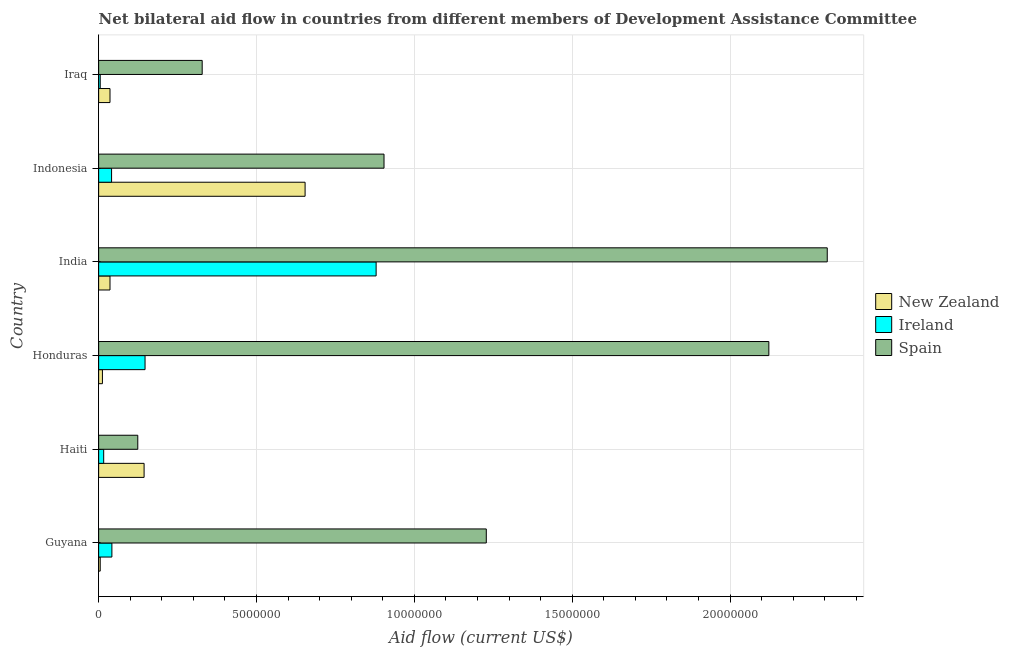How many groups of bars are there?
Make the answer very short. 6. Are the number of bars per tick equal to the number of legend labels?
Keep it short and to the point. Yes. Are the number of bars on each tick of the Y-axis equal?
Provide a succinct answer. Yes. How many bars are there on the 6th tick from the bottom?
Offer a very short reply. 3. What is the label of the 1st group of bars from the top?
Provide a short and direct response. Iraq. In how many cases, is the number of bars for a given country not equal to the number of legend labels?
Offer a terse response. 0. What is the amount of aid provided by spain in Guyana?
Your answer should be compact. 1.23e+07. Across all countries, what is the maximum amount of aid provided by ireland?
Ensure brevity in your answer.  8.79e+06. Across all countries, what is the minimum amount of aid provided by new zealand?
Make the answer very short. 5.00e+04. In which country was the amount of aid provided by spain maximum?
Ensure brevity in your answer.  India. In which country was the amount of aid provided by spain minimum?
Give a very brief answer. Haiti. What is the total amount of aid provided by spain in the graph?
Provide a succinct answer. 7.02e+07. What is the difference between the amount of aid provided by ireland in Haiti and that in Honduras?
Offer a terse response. -1.31e+06. What is the difference between the amount of aid provided by new zealand in Honduras and the amount of aid provided by ireland in Guyana?
Give a very brief answer. -3.00e+05. What is the average amount of aid provided by ireland per country?
Your answer should be compact. 1.88e+06. What is the difference between the amount of aid provided by ireland and amount of aid provided by new zealand in Indonesia?
Give a very brief answer. -6.13e+06. What is the ratio of the amount of aid provided by spain in Guyana to that in Iraq?
Offer a terse response. 3.74. Is the difference between the amount of aid provided by spain in India and Iraq greater than the difference between the amount of aid provided by ireland in India and Iraq?
Your response must be concise. Yes. What is the difference between the highest and the second highest amount of aid provided by new zealand?
Offer a very short reply. 5.10e+06. What is the difference between the highest and the lowest amount of aid provided by ireland?
Keep it short and to the point. 8.74e+06. Is the sum of the amount of aid provided by spain in Honduras and Iraq greater than the maximum amount of aid provided by ireland across all countries?
Provide a succinct answer. Yes. What does the 1st bar from the top in India represents?
Give a very brief answer. Spain. What does the 2nd bar from the bottom in India represents?
Your answer should be compact. Ireland. Is it the case that in every country, the sum of the amount of aid provided by new zealand and amount of aid provided by ireland is greater than the amount of aid provided by spain?
Give a very brief answer. No. How many bars are there?
Your answer should be compact. 18. Are all the bars in the graph horizontal?
Your answer should be compact. Yes. How many countries are there in the graph?
Keep it short and to the point. 6. What is the difference between two consecutive major ticks on the X-axis?
Your response must be concise. 5.00e+06. Does the graph contain any zero values?
Make the answer very short. No. Where does the legend appear in the graph?
Your response must be concise. Center right. What is the title of the graph?
Make the answer very short. Net bilateral aid flow in countries from different members of Development Assistance Committee. What is the Aid flow (current US$) of Ireland in Guyana?
Your response must be concise. 4.20e+05. What is the Aid flow (current US$) of Spain in Guyana?
Your answer should be compact. 1.23e+07. What is the Aid flow (current US$) in New Zealand in Haiti?
Keep it short and to the point. 1.44e+06. What is the Aid flow (current US$) in Spain in Haiti?
Offer a very short reply. 1.24e+06. What is the Aid flow (current US$) in Ireland in Honduras?
Offer a terse response. 1.47e+06. What is the Aid flow (current US$) in Spain in Honduras?
Provide a succinct answer. 2.12e+07. What is the Aid flow (current US$) in New Zealand in India?
Keep it short and to the point. 3.60e+05. What is the Aid flow (current US$) of Ireland in India?
Ensure brevity in your answer.  8.79e+06. What is the Aid flow (current US$) of Spain in India?
Make the answer very short. 2.31e+07. What is the Aid flow (current US$) of New Zealand in Indonesia?
Keep it short and to the point. 6.54e+06. What is the Aid flow (current US$) in Ireland in Indonesia?
Keep it short and to the point. 4.10e+05. What is the Aid flow (current US$) of Spain in Indonesia?
Provide a succinct answer. 9.04e+06. What is the Aid flow (current US$) of Ireland in Iraq?
Provide a succinct answer. 5.00e+04. What is the Aid flow (current US$) in Spain in Iraq?
Offer a very short reply. 3.28e+06. Across all countries, what is the maximum Aid flow (current US$) of New Zealand?
Offer a very short reply. 6.54e+06. Across all countries, what is the maximum Aid flow (current US$) of Ireland?
Ensure brevity in your answer.  8.79e+06. Across all countries, what is the maximum Aid flow (current US$) in Spain?
Provide a short and direct response. 2.31e+07. Across all countries, what is the minimum Aid flow (current US$) of Spain?
Your answer should be compact. 1.24e+06. What is the total Aid flow (current US$) in New Zealand in the graph?
Offer a very short reply. 8.87e+06. What is the total Aid flow (current US$) in Ireland in the graph?
Give a very brief answer. 1.13e+07. What is the total Aid flow (current US$) of Spain in the graph?
Provide a succinct answer. 7.02e+07. What is the difference between the Aid flow (current US$) of New Zealand in Guyana and that in Haiti?
Provide a succinct answer. -1.39e+06. What is the difference between the Aid flow (current US$) of Ireland in Guyana and that in Haiti?
Keep it short and to the point. 2.60e+05. What is the difference between the Aid flow (current US$) of Spain in Guyana and that in Haiti?
Offer a very short reply. 1.10e+07. What is the difference between the Aid flow (current US$) in Ireland in Guyana and that in Honduras?
Your answer should be compact. -1.05e+06. What is the difference between the Aid flow (current US$) in Spain in Guyana and that in Honduras?
Make the answer very short. -8.95e+06. What is the difference between the Aid flow (current US$) in New Zealand in Guyana and that in India?
Offer a very short reply. -3.10e+05. What is the difference between the Aid flow (current US$) in Ireland in Guyana and that in India?
Give a very brief answer. -8.37e+06. What is the difference between the Aid flow (current US$) in Spain in Guyana and that in India?
Provide a short and direct response. -1.08e+07. What is the difference between the Aid flow (current US$) in New Zealand in Guyana and that in Indonesia?
Your answer should be very brief. -6.49e+06. What is the difference between the Aid flow (current US$) in Ireland in Guyana and that in Indonesia?
Your answer should be very brief. 10000. What is the difference between the Aid flow (current US$) of Spain in Guyana and that in Indonesia?
Your response must be concise. 3.24e+06. What is the difference between the Aid flow (current US$) in New Zealand in Guyana and that in Iraq?
Your answer should be very brief. -3.10e+05. What is the difference between the Aid flow (current US$) in Ireland in Guyana and that in Iraq?
Ensure brevity in your answer.  3.70e+05. What is the difference between the Aid flow (current US$) of Spain in Guyana and that in Iraq?
Your answer should be very brief. 9.00e+06. What is the difference between the Aid flow (current US$) of New Zealand in Haiti and that in Honduras?
Your answer should be very brief. 1.32e+06. What is the difference between the Aid flow (current US$) of Ireland in Haiti and that in Honduras?
Provide a succinct answer. -1.31e+06. What is the difference between the Aid flow (current US$) in Spain in Haiti and that in Honduras?
Provide a short and direct response. -2.00e+07. What is the difference between the Aid flow (current US$) of New Zealand in Haiti and that in India?
Keep it short and to the point. 1.08e+06. What is the difference between the Aid flow (current US$) of Ireland in Haiti and that in India?
Ensure brevity in your answer.  -8.63e+06. What is the difference between the Aid flow (current US$) of Spain in Haiti and that in India?
Make the answer very short. -2.18e+07. What is the difference between the Aid flow (current US$) in New Zealand in Haiti and that in Indonesia?
Offer a terse response. -5.10e+06. What is the difference between the Aid flow (current US$) in Ireland in Haiti and that in Indonesia?
Provide a short and direct response. -2.50e+05. What is the difference between the Aid flow (current US$) in Spain in Haiti and that in Indonesia?
Keep it short and to the point. -7.80e+06. What is the difference between the Aid flow (current US$) of New Zealand in Haiti and that in Iraq?
Your answer should be compact. 1.08e+06. What is the difference between the Aid flow (current US$) in Spain in Haiti and that in Iraq?
Keep it short and to the point. -2.04e+06. What is the difference between the Aid flow (current US$) in New Zealand in Honduras and that in India?
Offer a terse response. -2.40e+05. What is the difference between the Aid flow (current US$) in Ireland in Honduras and that in India?
Your answer should be very brief. -7.32e+06. What is the difference between the Aid flow (current US$) of Spain in Honduras and that in India?
Provide a short and direct response. -1.85e+06. What is the difference between the Aid flow (current US$) in New Zealand in Honduras and that in Indonesia?
Offer a terse response. -6.42e+06. What is the difference between the Aid flow (current US$) of Ireland in Honduras and that in Indonesia?
Your response must be concise. 1.06e+06. What is the difference between the Aid flow (current US$) in Spain in Honduras and that in Indonesia?
Make the answer very short. 1.22e+07. What is the difference between the Aid flow (current US$) in Ireland in Honduras and that in Iraq?
Provide a succinct answer. 1.42e+06. What is the difference between the Aid flow (current US$) in Spain in Honduras and that in Iraq?
Your answer should be compact. 1.80e+07. What is the difference between the Aid flow (current US$) of New Zealand in India and that in Indonesia?
Give a very brief answer. -6.18e+06. What is the difference between the Aid flow (current US$) in Ireland in India and that in Indonesia?
Provide a short and direct response. 8.38e+06. What is the difference between the Aid flow (current US$) of Spain in India and that in Indonesia?
Make the answer very short. 1.40e+07. What is the difference between the Aid flow (current US$) of Ireland in India and that in Iraq?
Your answer should be very brief. 8.74e+06. What is the difference between the Aid flow (current US$) in Spain in India and that in Iraq?
Offer a very short reply. 1.98e+07. What is the difference between the Aid flow (current US$) in New Zealand in Indonesia and that in Iraq?
Make the answer very short. 6.18e+06. What is the difference between the Aid flow (current US$) in Ireland in Indonesia and that in Iraq?
Your response must be concise. 3.60e+05. What is the difference between the Aid flow (current US$) in Spain in Indonesia and that in Iraq?
Offer a very short reply. 5.76e+06. What is the difference between the Aid flow (current US$) of New Zealand in Guyana and the Aid flow (current US$) of Ireland in Haiti?
Provide a short and direct response. -1.10e+05. What is the difference between the Aid flow (current US$) of New Zealand in Guyana and the Aid flow (current US$) of Spain in Haiti?
Make the answer very short. -1.19e+06. What is the difference between the Aid flow (current US$) in Ireland in Guyana and the Aid flow (current US$) in Spain in Haiti?
Provide a short and direct response. -8.20e+05. What is the difference between the Aid flow (current US$) in New Zealand in Guyana and the Aid flow (current US$) in Ireland in Honduras?
Provide a succinct answer. -1.42e+06. What is the difference between the Aid flow (current US$) in New Zealand in Guyana and the Aid flow (current US$) in Spain in Honduras?
Your answer should be very brief. -2.12e+07. What is the difference between the Aid flow (current US$) in Ireland in Guyana and the Aid flow (current US$) in Spain in Honduras?
Offer a very short reply. -2.08e+07. What is the difference between the Aid flow (current US$) in New Zealand in Guyana and the Aid flow (current US$) in Ireland in India?
Your response must be concise. -8.74e+06. What is the difference between the Aid flow (current US$) in New Zealand in Guyana and the Aid flow (current US$) in Spain in India?
Provide a short and direct response. -2.30e+07. What is the difference between the Aid flow (current US$) in Ireland in Guyana and the Aid flow (current US$) in Spain in India?
Your response must be concise. -2.27e+07. What is the difference between the Aid flow (current US$) in New Zealand in Guyana and the Aid flow (current US$) in Ireland in Indonesia?
Ensure brevity in your answer.  -3.60e+05. What is the difference between the Aid flow (current US$) in New Zealand in Guyana and the Aid flow (current US$) in Spain in Indonesia?
Your answer should be very brief. -8.99e+06. What is the difference between the Aid flow (current US$) in Ireland in Guyana and the Aid flow (current US$) in Spain in Indonesia?
Your answer should be compact. -8.62e+06. What is the difference between the Aid flow (current US$) of New Zealand in Guyana and the Aid flow (current US$) of Spain in Iraq?
Provide a short and direct response. -3.23e+06. What is the difference between the Aid flow (current US$) of Ireland in Guyana and the Aid flow (current US$) of Spain in Iraq?
Make the answer very short. -2.86e+06. What is the difference between the Aid flow (current US$) in New Zealand in Haiti and the Aid flow (current US$) in Ireland in Honduras?
Your answer should be compact. -3.00e+04. What is the difference between the Aid flow (current US$) in New Zealand in Haiti and the Aid flow (current US$) in Spain in Honduras?
Offer a terse response. -1.98e+07. What is the difference between the Aid flow (current US$) in Ireland in Haiti and the Aid flow (current US$) in Spain in Honduras?
Your answer should be very brief. -2.11e+07. What is the difference between the Aid flow (current US$) of New Zealand in Haiti and the Aid flow (current US$) of Ireland in India?
Make the answer very short. -7.35e+06. What is the difference between the Aid flow (current US$) in New Zealand in Haiti and the Aid flow (current US$) in Spain in India?
Ensure brevity in your answer.  -2.16e+07. What is the difference between the Aid flow (current US$) in Ireland in Haiti and the Aid flow (current US$) in Spain in India?
Your answer should be very brief. -2.29e+07. What is the difference between the Aid flow (current US$) of New Zealand in Haiti and the Aid flow (current US$) of Ireland in Indonesia?
Offer a very short reply. 1.03e+06. What is the difference between the Aid flow (current US$) of New Zealand in Haiti and the Aid flow (current US$) of Spain in Indonesia?
Make the answer very short. -7.60e+06. What is the difference between the Aid flow (current US$) in Ireland in Haiti and the Aid flow (current US$) in Spain in Indonesia?
Offer a terse response. -8.88e+06. What is the difference between the Aid flow (current US$) in New Zealand in Haiti and the Aid flow (current US$) in Ireland in Iraq?
Make the answer very short. 1.39e+06. What is the difference between the Aid flow (current US$) of New Zealand in Haiti and the Aid flow (current US$) of Spain in Iraq?
Make the answer very short. -1.84e+06. What is the difference between the Aid flow (current US$) in Ireland in Haiti and the Aid flow (current US$) in Spain in Iraq?
Your answer should be compact. -3.12e+06. What is the difference between the Aid flow (current US$) of New Zealand in Honduras and the Aid flow (current US$) of Ireland in India?
Keep it short and to the point. -8.67e+06. What is the difference between the Aid flow (current US$) in New Zealand in Honduras and the Aid flow (current US$) in Spain in India?
Provide a succinct answer. -2.30e+07. What is the difference between the Aid flow (current US$) of Ireland in Honduras and the Aid flow (current US$) of Spain in India?
Offer a terse response. -2.16e+07. What is the difference between the Aid flow (current US$) in New Zealand in Honduras and the Aid flow (current US$) in Ireland in Indonesia?
Give a very brief answer. -2.90e+05. What is the difference between the Aid flow (current US$) in New Zealand in Honduras and the Aid flow (current US$) in Spain in Indonesia?
Your answer should be compact. -8.92e+06. What is the difference between the Aid flow (current US$) of Ireland in Honduras and the Aid flow (current US$) of Spain in Indonesia?
Offer a terse response. -7.57e+06. What is the difference between the Aid flow (current US$) in New Zealand in Honduras and the Aid flow (current US$) in Ireland in Iraq?
Keep it short and to the point. 7.00e+04. What is the difference between the Aid flow (current US$) of New Zealand in Honduras and the Aid flow (current US$) of Spain in Iraq?
Offer a very short reply. -3.16e+06. What is the difference between the Aid flow (current US$) of Ireland in Honduras and the Aid flow (current US$) of Spain in Iraq?
Provide a short and direct response. -1.81e+06. What is the difference between the Aid flow (current US$) of New Zealand in India and the Aid flow (current US$) of Ireland in Indonesia?
Ensure brevity in your answer.  -5.00e+04. What is the difference between the Aid flow (current US$) of New Zealand in India and the Aid flow (current US$) of Spain in Indonesia?
Provide a short and direct response. -8.68e+06. What is the difference between the Aid flow (current US$) of Ireland in India and the Aid flow (current US$) of Spain in Indonesia?
Your answer should be compact. -2.50e+05. What is the difference between the Aid flow (current US$) of New Zealand in India and the Aid flow (current US$) of Ireland in Iraq?
Provide a short and direct response. 3.10e+05. What is the difference between the Aid flow (current US$) of New Zealand in India and the Aid flow (current US$) of Spain in Iraq?
Make the answer very short. -2.92e+06. What is the difference between the Aid flow (current US$) of Ireland in India and the Aid flow (current US$) of Spain in Iraq?
Offer a terse response. 5.51e+06. What is the difference between the Aid flow (current US$) of New Zealand in Indonesia and the Aid flow (current US$) of Ireland in Iraq?
Provide a short and direct response. 6.49e+06. What is the difference between the Aid flow (current US$) in New Zealand in Indonesia and the Aid flow (current US$) in Spain in Iraq?
Provide a succinct answer. 3.26e+06. What is the difference between the Aid flow (current US$) in Ireland in Indonesia and the Aid flow (current US$) in Spain in Iraq?
Offer a very short reply. -2.87e+06. What is the average Aid flow (current US$) in New Zealand per country?
Offer a very short reply. 1.48e+06. What is the average Aid flow (current US$) of Ireland per country?
Provide a short and direct response. 1.88e+06. What is the average Aid flow (current US$) of Spain per country?
Your answer should be very brief. 1.17e+07. What is the difference between the Aid flow (current US$) of New Zealand and Aid flow (current US$) of Ireland in Guyana?
Give a very brief answer. -3.70e+05. What is the difference between the Aid flow (current US$) in New Zealand and Aid flow (current US$) in Spain in Guyana?
Give a very brief answer. -1.22e+07. What is the difference between the Aid flow (current US$) in Ireland and Aid flow (current US$) in Spain in Guyana?
Keep it short and to the point. -1.19e+07. What is the difference between the Aid flow (current US$) of New Zealand and Aid flow (current US$) of Ireland in Haiti?
Ensure brevity in your answer.  1.28e+06. What is the difference between the Aid flow (current US$) of Ireland and Aid flow (current US$) of Spain in Haiti?
Keep it short and to the point. -1.08e+06. What is the difference between the Aid flow (current US$) in New Zealand and Aid flow (current US$) in Ireland in Honduras?
Provide a short and direct response. -1.35e+06. What is the difference between the Aid flow (current US$) in New Zealand and Aid flow (current US$) in Spain in Honduras?
Your response must be concise. -2.11e+07. What is the difference between the Aid flow (current US$) of Ireland and Aid flow (current US$) of Spain in Honduras?
Offer a terse response. -1.98e+07. What is the difference between the Aid flow (current US$) of New Zealand and Aid flow (current US$) of Ireland in India?
Your answer should be compact. -8.43e+06. What is the difference between the Aid flow (current US$) of New Zealand and Aid flow (current US$) of Spain in India?
Your response must be concise. -2.27e+07. What is the difference between the Aid flow (current US$) of Ireland and Aid flow (current US$) of Spain in India?
Your answer should be very brief. -1.43e+07. What is the difference between the Aid flow (current US$) of New Zealand and Aid flow (current US$) of Ireland in Indonesia?
Provide a short and direct response. 6.13e+06. What is the difference between the Aid flow (current US$) of New Zealand and Aid flow (current US$) of Spain in Indonesia?
Provide a short and direct response. -2.50e+06. What is the difference between the Aid flow (current US$) of Ireland and Aid flow (current US$) of Spain in Indonesia?
Provide a succinct answer. -8.63e+06. What is the difference between the Aid flow (current US$) in New Zealand and Aid flow (current US$) in Spain in Iraq?
Give a very brief answer. -2.92e+06. What is the difference between the Aid flow (current US$) of Ireland and Aid flow (current US$) of Spain in Iraq?
Keep it short and to the point. -3.23e+06. What is the ratio of the Aid flow (current US$) of New Zealand in Guyana to that in Haiti?
Provide a short and direct response. 0.03. What is the ratio of the Aid flow (current US$) of Ireland in Guyana to that in Haiti?
Provide a succinct answer. 2.62. What is the ratio of the Aid flow (current US$) of Spain in Guyana to that in Haiti?
Provide a short and direct response. 9.9. What is the ratio of the Aid flow (current US$) in New Zealand in Guyana to that in Honduras?
Make the answer very short. 0.42. What is the ratio of the Aid flow (current US$) in Ireland in Guyana to that in Honduras?
Your response must be concise. 0.29. What is the ratio of the Aid flow (current US$) of Spain in Guyana to that in Honduras?
Give a very brief answer. 0.58. What is the ratio of the Aid flow (current US$) in New Zealand in Guyana to that in India?
Offer a terse response. 0.14. What is the ratio of the Aid flow (current US$) in Ireland in Guyana to that in India?
Your answer should be very brief. 0.05. What is the ratio of the Aid flow (current US$) of Spain in Guyana to that in India?
Your answer should be compact. 0.53. What is the ratio of the Aid flow (current US$) in New Zealand in Guyana to that in Indonesia?
Give a very brief answer. 0.01. What is the ratio of the Aid flow (current US$) of Ireland in Guyana to that in Indonesia?
Offer a terse response. 1.02. What is the ratio of the Aid flow (current US$) of Spain in Guyana to that in Indonesia?
Make the answer very short. 1.36. What is the ratio of the Aid flow (current US$) in New Zealand in Guyana to that in Iraq?
Your answer should be compact. 0.14. What is the ratio of the Aid flow (current US$) in Spain in Guyana to that in Iraq?
Give a very brief answer. 3.74. What is the ratio of the Aid flow (current US$) of New Zealand in Haiti to that in Honduras?
Ensure brevity in your answer.  12. What is the ratio of the Aid flow (current US$) of Ireland in Haiti to that in Honduras?
Offer a terse response. 0.11. What is the ratio of the Aid flow (current US$) of Spain in Haiti to that in Honduras?
Your answer should be compact. 0.06. What is the ratio of the Aid flow (current US$) in Ireland in Haiti to that in India?
Offer a very short reply. 0.02. What is the ratio of the Aid flow (current US$) of Spain in Haiti to that in India?
Keep it short and to the point. 0.05. What is the ratio of the Aid flow (current US$) of New Zealand in Haiti to that in Indonesia?
Your response must be concise. 0.22. What is the ratio of the Aid flow (current US$) in Ireland in Haiti to that in Indonesia?
Make the answer very short. 0.39. What is the ratio of the Aid flow (current US$) in Spain in Haiti to that in Indonesia?
Provide a short and direct response. 0.14. What is the ratio of the Aid flow (current US$) of New Zealand in Haiti to that in Iraq?
Your response must be concise. 4. What is the ratio of the Aid flow (current US$) of Ireland in Haiti to that in Iraq?
Your answer should be compact. 3.2. What is the ratio of the Aid flow (current US$) in Spain in Haiti to that in Iraq?
Offer a very short reply. 0.38. What is the ratio of the Aid flow (current US$) in New Zealand in Honduras to that in India?
Provide a succinct answer. 0.33. What is the ratio of the Aid flow (current US$) of Ireland in Honduras to that in India?
Provide a short and direct response. 0.17. What is the ratio of the Aid flow (current US$) of Spain in Honduras to that in India?
Provide a succinct answer. 0.92. What is the ratio of the Aid flow (current US$) in New Zealand in Honduras to that in Indonesia?
Provide a succinct answer. 0.02. What is the ratio of the Aid flow (current US$) in Ireland in Honduras to that in Indonesia?
Provide a short and direct response. 3.59. What is the ratio of the Aid flow (current US$) in Spain in Honduras to that in Indonesia?
Provide a succinct answer. 2.35. What is the ratio of the Aid flow (current US$) in New Zealand in Honduras to that in Iraq?
Provide a succinct answer. 0.33. What is the ratio of the Aid flow (current US$) in Ireland in Honduras to that in Iraq?
Give a very brief answer. 29.4. What is the ratio of the Aid flow (current US$) in Spain in Honduras to that in Iraq?
Provide a succinct answer. 6.47. What is the ratio of the Aid flow (current US$) of New Zealand in India to that in Indonesia?
Keep it short and to the point. 0.06. What is the ratio of the Aid flow (current US$) of Ireland in India to that in Indonesia?
Ensure brevity in your answer.  21.44. What is the ratio of the Aid flow (current US$) in Spain in India to that in Indonesia?
Offer a terse response. 2.55. What is the ratio of the Aid flow (current US$) of Ireland in India to that in Iraq?
Make the answer very short. 175.8. What is the ratio of the Aid flow (current US$) of Spain in India to that in Iraq?
Your answer should be compact. 7.04. What is the ratio of the Aid flow (current US$) of New Zealand in Indonesia to that in Iraq?
Make the answer very short. 18.17. What is the ratio of the Aid flow (current US$) in Spain in Indonesia to that in Iraq?
Offer a very short reply. 2.76. What is the difference between the highest and the second highest Aid flow (current US$) in New Zealand?
Give a very brief answer. 5.10e+06. What is the difference between the highest and the second highest Aid flow (current US$) of Ireland?
Keep it short and to the point. 7.32e+06. What is the difference between the highest and the second highest Aid flow (current US$) in Spain?
Ensure brevity in your answer.  1.85e+06. What is the difference between the highest and the lowest Aid flow (current US$) in New Zealand?
Ensure brevity in your answer.  6.49e+06. What is the difference between the highest and the lowest Aid flow (current US$) in Ireland?
Keep it short and to the point. 8.74e+06. What is the difference between the highest and the lowest Aid flow (current US$) in Spain?
Offer a terse response. 2.18e+07. 